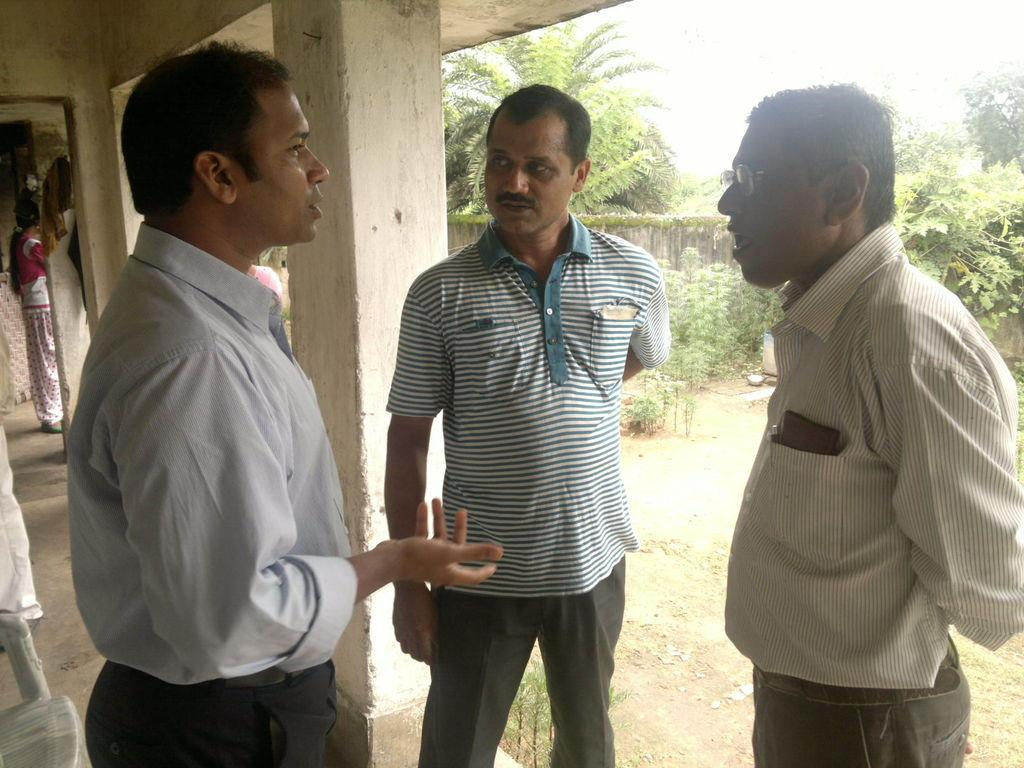How many people are in the image? There are three persons standing in the foreground of the image. What can be seen in the background of the image? There are trees in the background of the image. What type of structure is present in the image? There is a wall in the image. What type of education can be seen taking place in the image? There is no indication of any educational activity taking place in the image. 